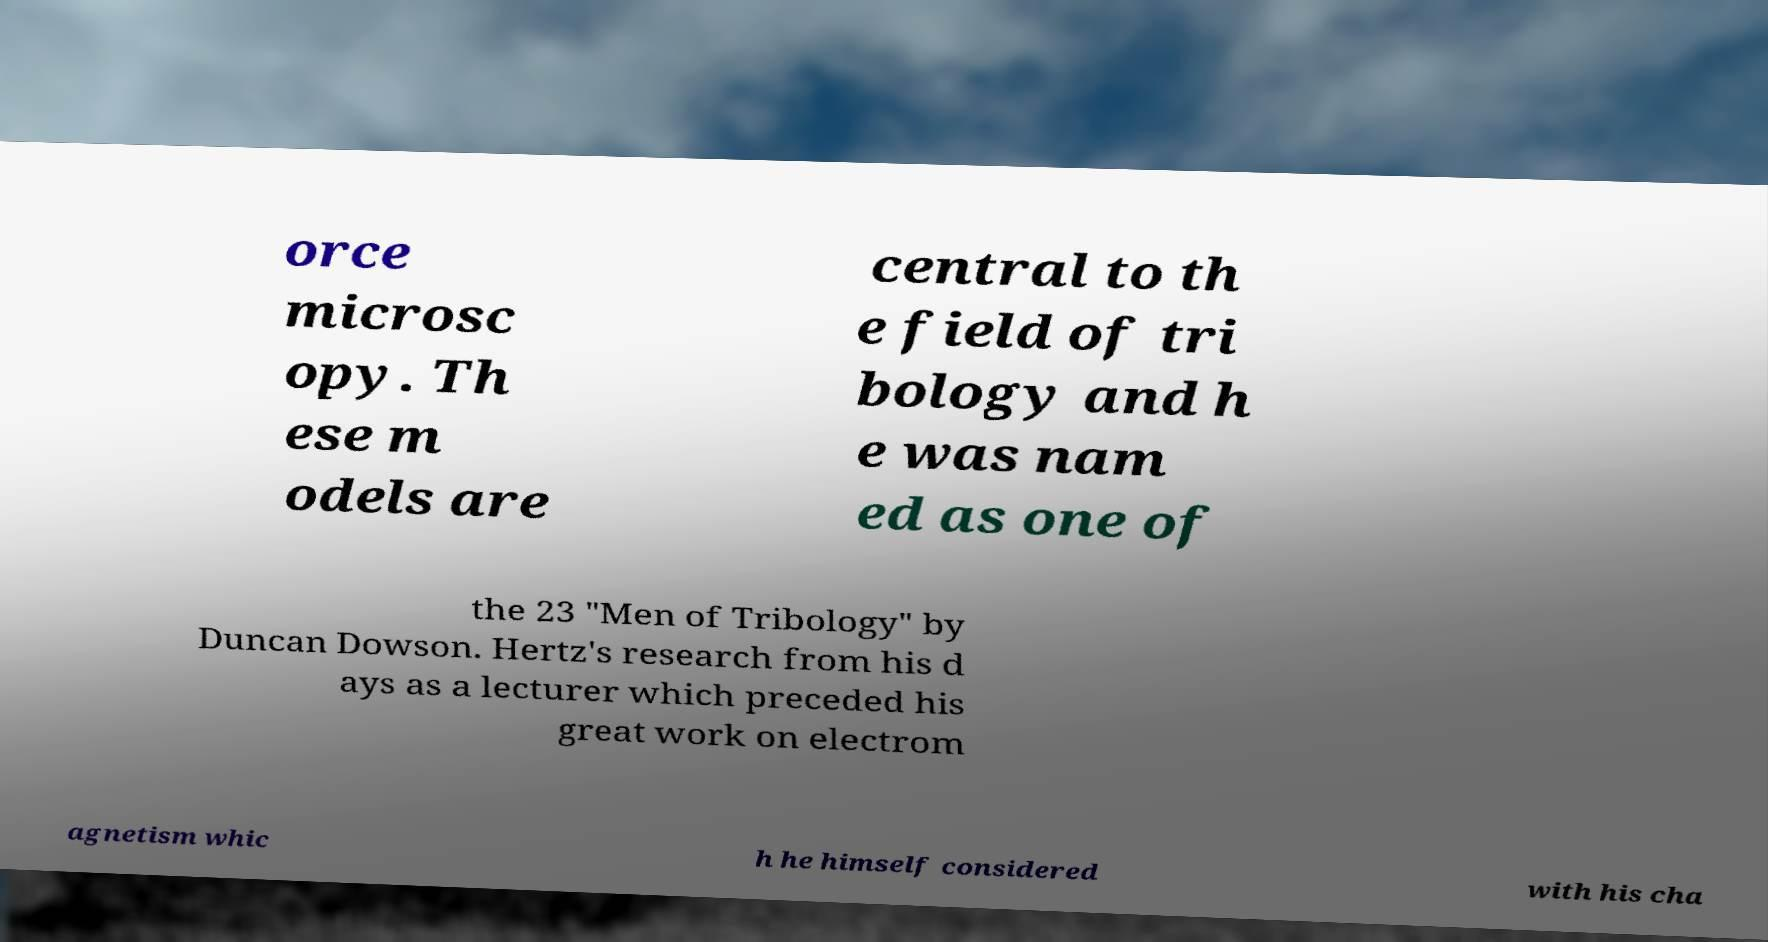I need the written content from this picture converted into text. Can you do that? orce microsc opy. Th ese m odels are central to th e field of tri bology and h e was nam ed as one of the 23 "Men of Tribology" by Duncan Dowson. Hertz's research from his d ays as a lecturer which preceded his great work on electrom agnetism whic h he himself considered with his cha 